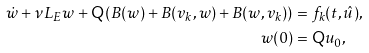Convert formula to latex. <formula><loc_0><loc_0><loc_500><loc_500>\dot { w } + \nu L _ { E } w + { \mathsf Q } \left ( B ( w ) + B ( v _ { k } , w ) + B ( w , v _ { k } ) \right ) & = f _ { k } ( t , \hat { u } ) , \\ w ( 0 ) & = { \mathsf Q } u _ { 0 } ,</formula> 